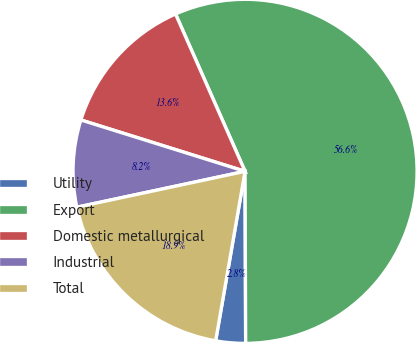Convert chart. <chart><loc_0><loc_0><loc_500><loc_500><pie_chart><fcel>Utility<fcel>Export<fcel>Domestic metallurgical<fcel>Industrial<fcel>Total<nl><fcel>2.79%<fcel>56.56%<fcel>13.55%<fcel>8.17%<fcel>18.92%<nl></chart> 